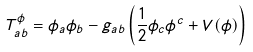<formula> <loc_0><loc_0><loc_500><loc_500>T ^ { \phi } _ { a b } = \phi _ { a } \phi _ { b } - g _ { a b } \left ( \frac { 1 } { 2 } \phi _ { c } \phi ^ { c } + V ( \phi ) \right )</formula> 